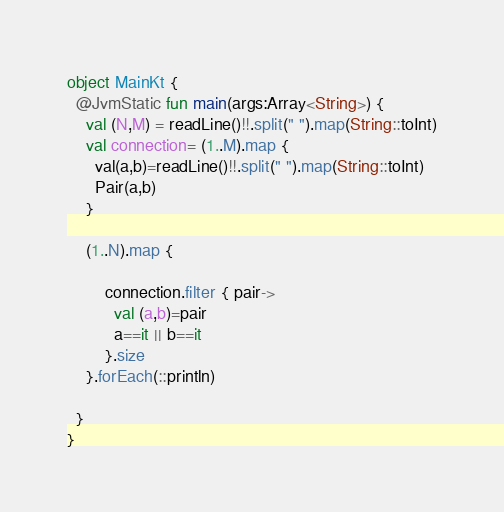Convert code to text. <code><loc_0><loc_0><loc_500><loc_500><_Kotlin_>
object MainKt {
  @JvmStatic fun main(args:Array<String>) {
    val (N,M) = readLine()!!.split(" ").map(String::toInt)
    val connection= (1..M).map {
      val(a,b)=readLine()!!.split(" ").map(String::toInt)
      Pair(a,b)
    }
  
    (1..N).map {
    
        connection.filter { pair->
          val (a,b)=pair
          a==it || b==it
        }.size
    }.forEach(::println)

  }
}</code> 